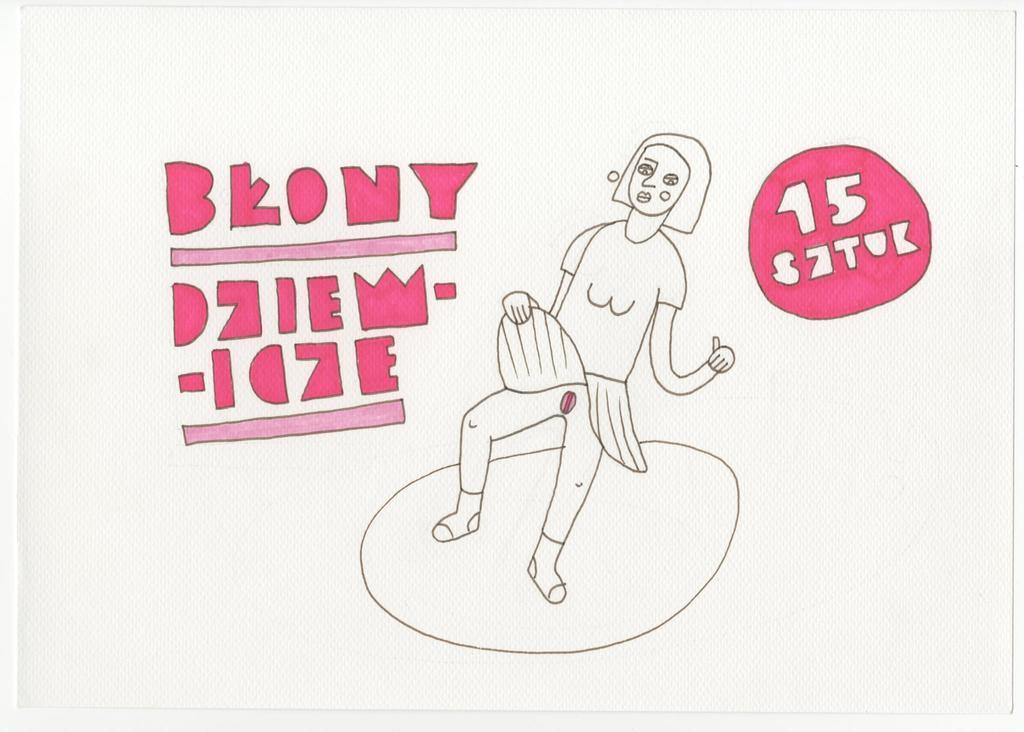How would you summarize this image in a sentence or two? In this image I can see a white colour tissue paper like thing and on it I can see a sketch. I can also see something is written on the both sides of the tissue paper. 